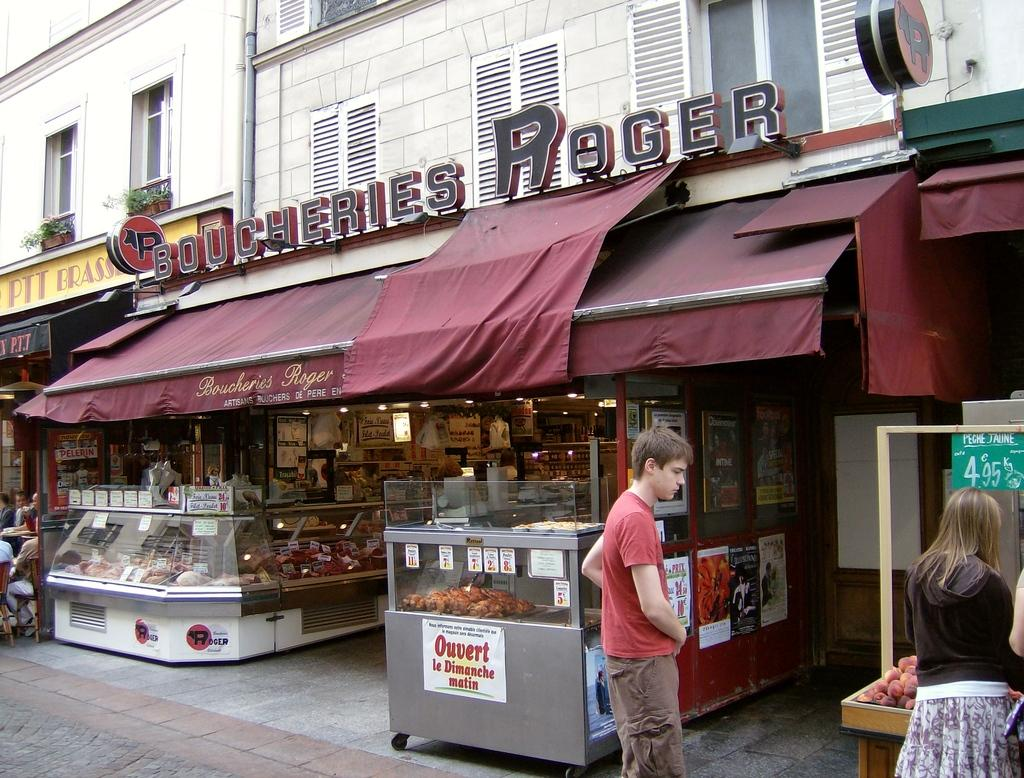Provide a one-sentence caption for the provided image. The shop shown is a Boucheries Roger shop selling cuts of meat. 